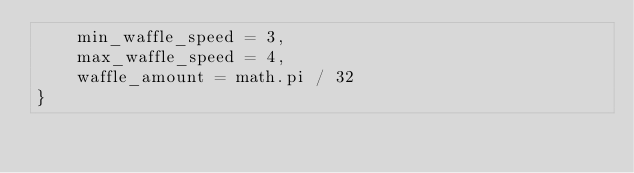<code> <loc_0><loc_0><loc_500><loc_500><_Lua_>	min_waffle_speed = 3,
	max_waffle_speed = 4,
	waffle_amount = math.pi / 32
}</code> 